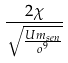<formula> <loc_0><loc_0><loc_500><loc_500>\frac { 2 \chi } { \sqrt { \frac { U m _ { s e n } } { o ^ { 9 } } } }</formula> 